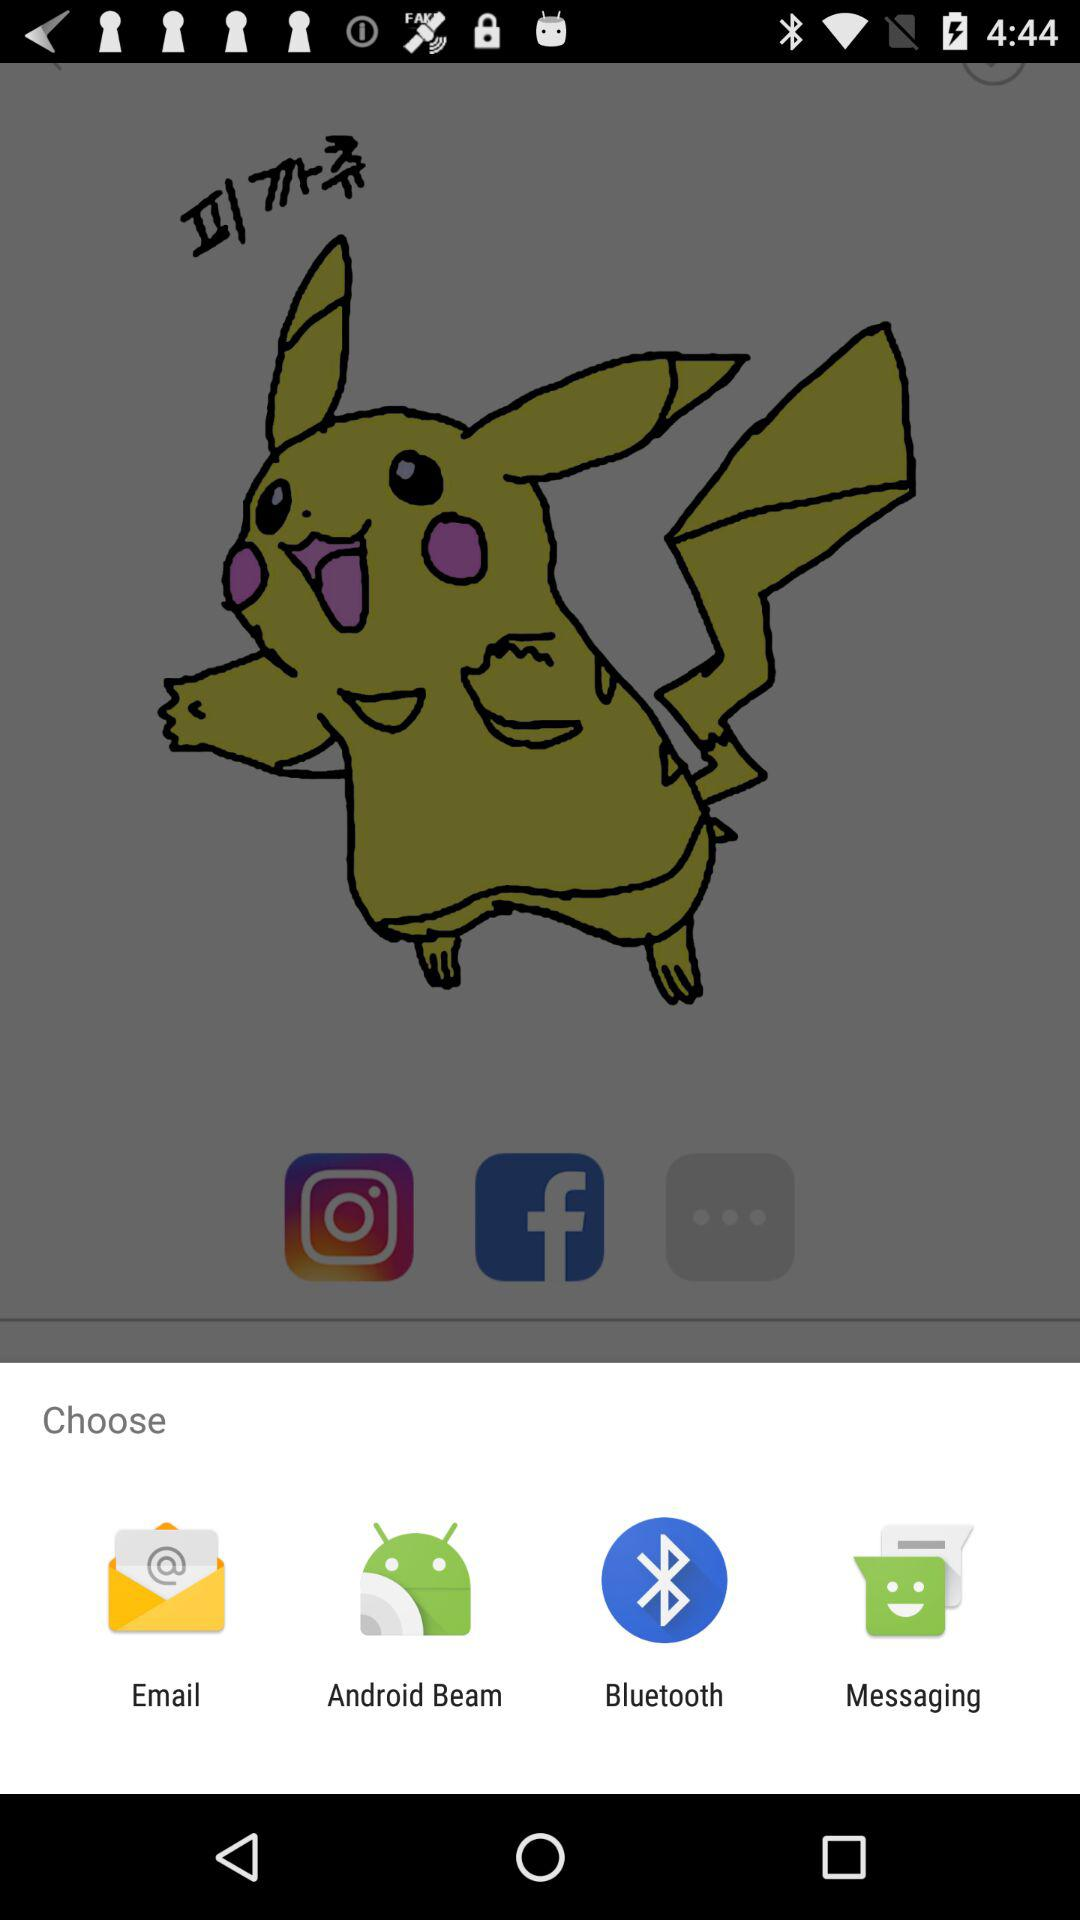What applications can be used to choose? The applications are "Email", "Android Beam", "Bluetooth" and "Browser". 